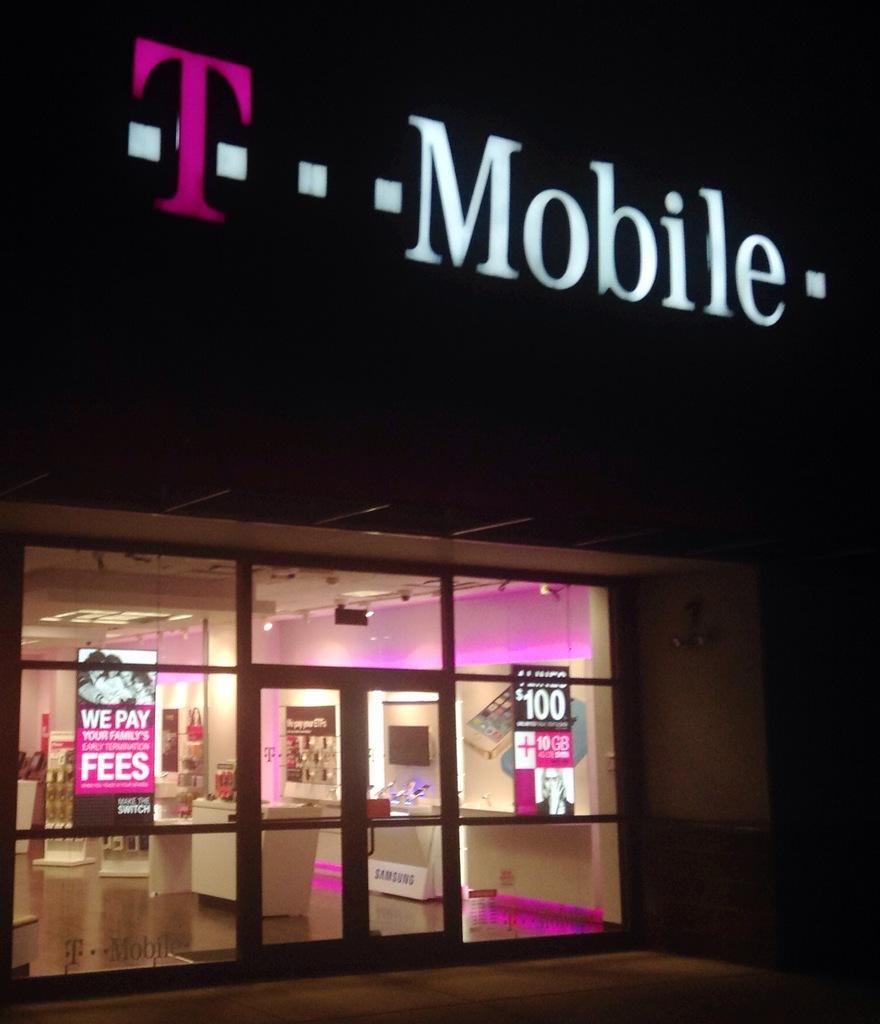Please provide a concise description of this image. In this image we can see a store, mobiles arranged in the racks, advertisement boards and a name board. 